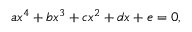Convert formula to latex. <formula><loc_0><loc_0><loc_500><loc_500>a x ^ { 4 } + b x ^ { 3 } + c x ^ { 2 } + d x + e = 0 ,</formula> 